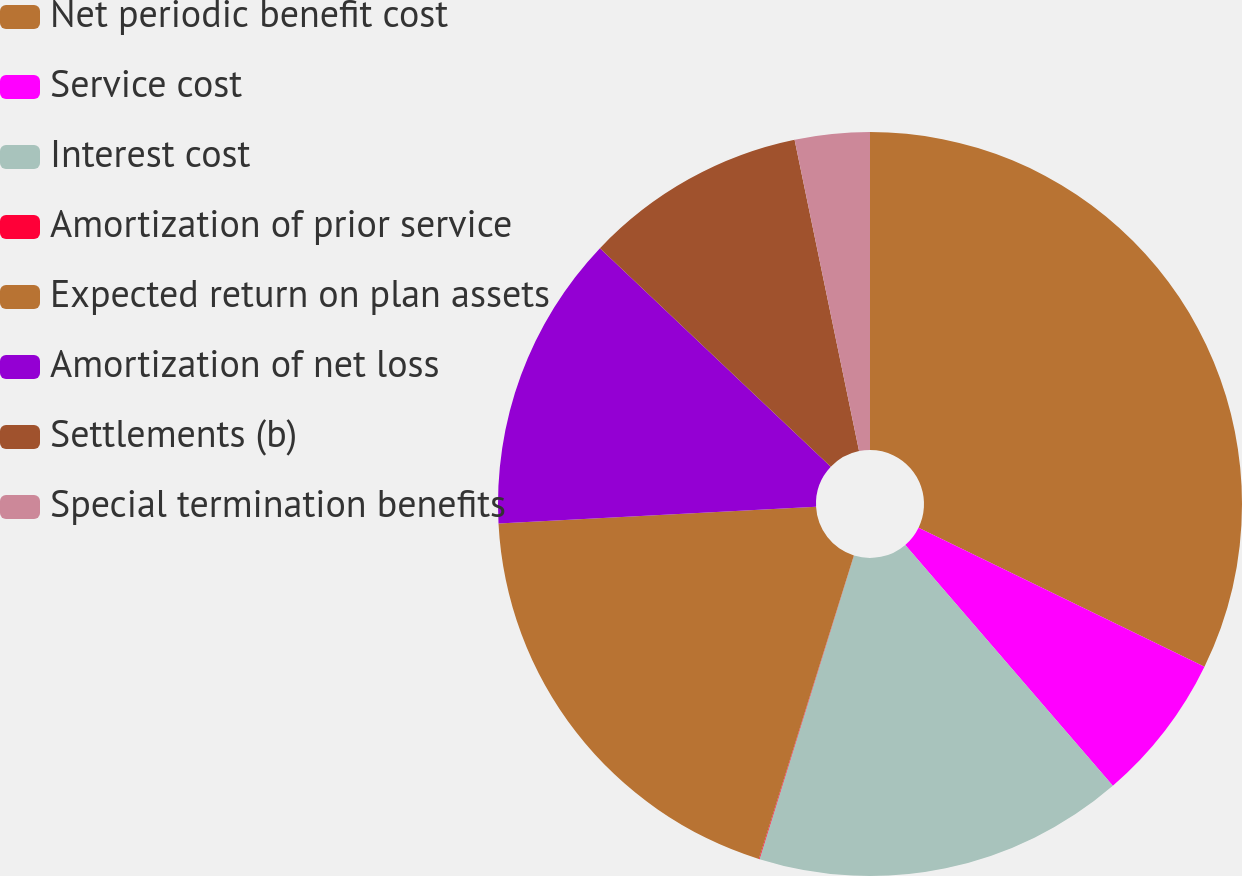Convert chart to OTSL. <chart><loc_0><loc_0><loc_500><loc_500><pie_chart><fcel>Net periodic benefit cost<fcel>Service cost<fcel>Interest cost<fcel>Amortization of prior service<fcel>Expected return on plan assets<fcel>Amortization of net loss<fcel>Settlements (b)<fcel>Special termination benefits<nl><fcel>32.21%<fcel>6.47%<fcel>16.12%<fcel>0.03%<fcel>19.34%<fcel>12.9%<fcel>9.68%<fcel>3.25%<nl></chart> 